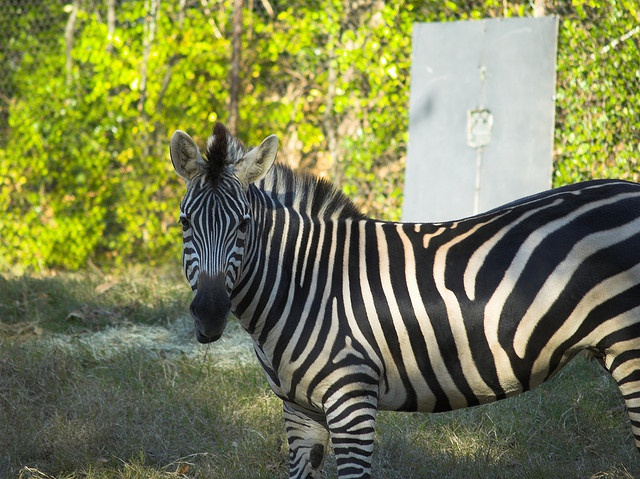Describe the objects in this image and their specific colors. I can see a zebra in darkgreen, black, gray, darkgray, and beige tones in this image. 